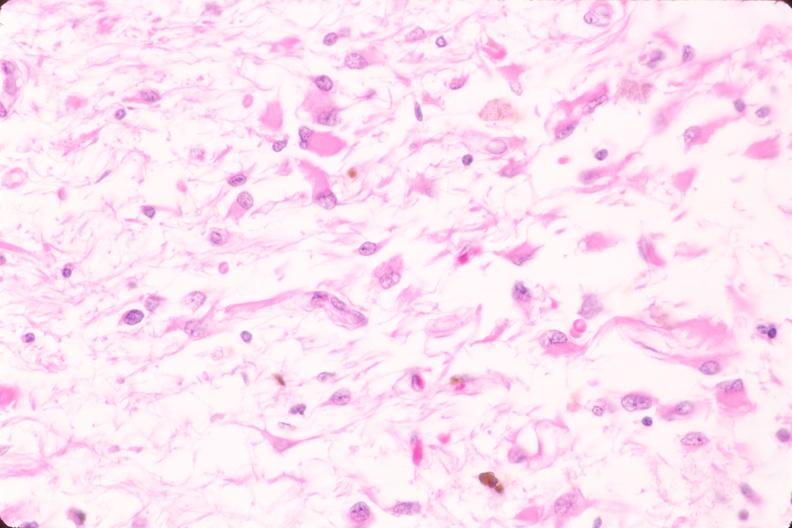does this image show brain, infarct due to ruptured saccular aneurysm and thrombosis of right middle cerebral artery, plasmacytic astrocytes?
Answer the question using a single word or phrase. Yes 